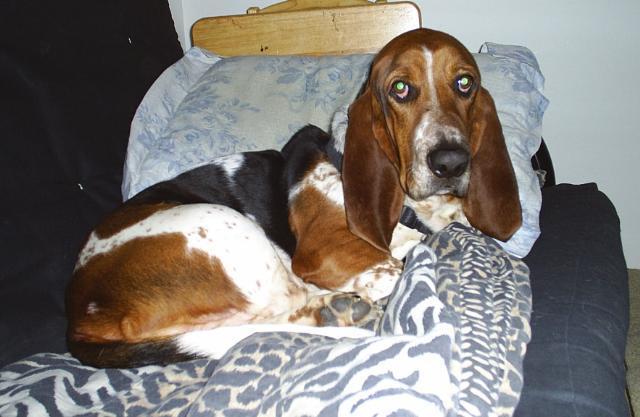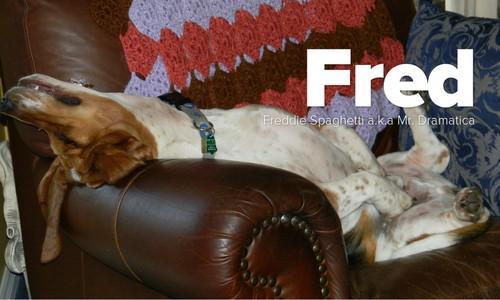The first image is the image on the left, the second image is the image on the right. Assess this claim about the two images: "In one of the images two mammals can be seen wearing hats.". Correct or not? Answer yes or no. No. The first image is the image on the left, the second image is the image on the right. For the images displayed, is the sentence "One image with at least one camera-facing basset hound in it also contains two hats." factually correct? Answer yes or no. No. 